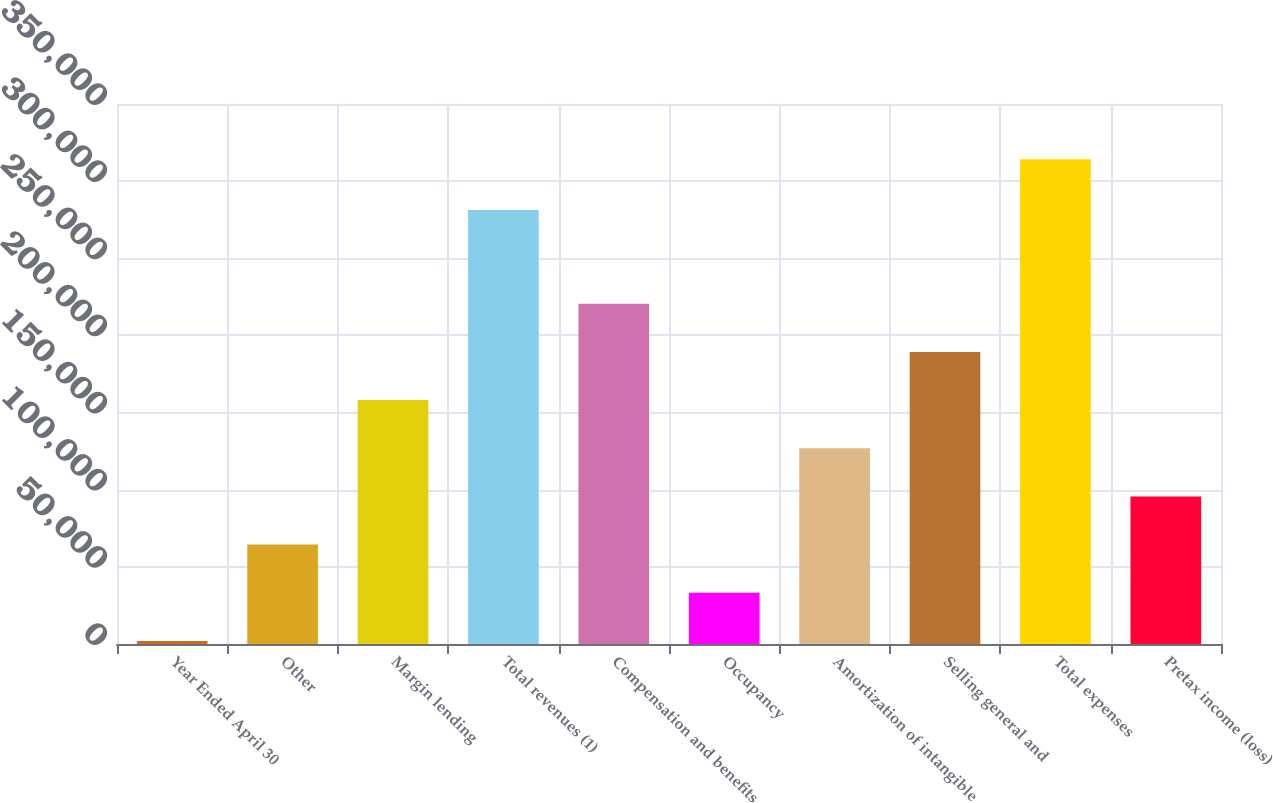Convert chart to OTSL. <chart><loc_0><loc_0><loc_500><loc_500><bar_chart><fcel>Year Ended April 30<fcel>Other<fcel>Margin lending<fcel>Total revenues (1)<fcel>Compensation and benefits<fcel>Occupancy<fcel>Amortization of intangible<fcel>Selling general and<fcel>Total expenses<fcel>Pretax income (loss)<nl><fcel>2006<fcel>64434.2<fcel>158076<fcel>281312<fcel>220505<fcel>33220.1<fcel>126862<fcel>189291<fcel>314147<fcel>95648.3<nl></chart> 